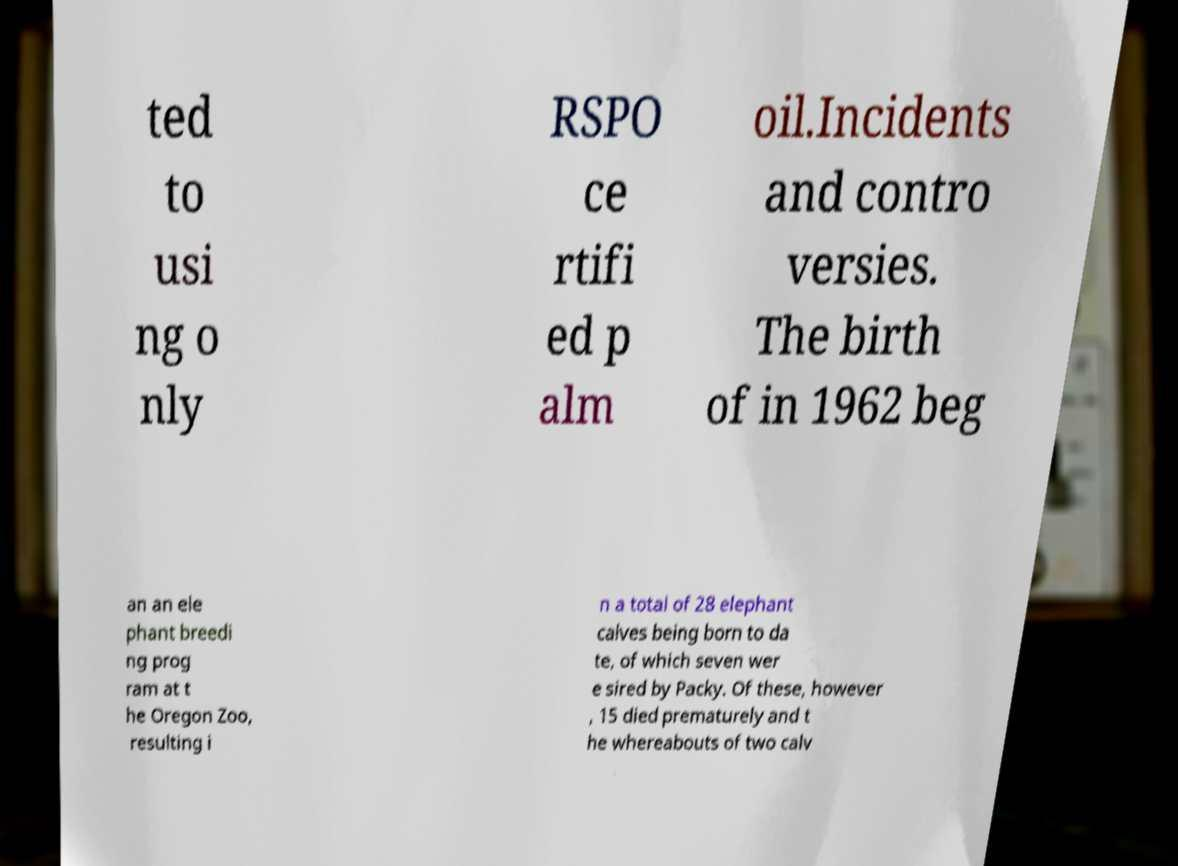Please identify and transcribe the text found in this image. ted to usi ng o nly RSPO ce rtifi ed p alm oil.Incidents and contro versies. The birth of in 1962 beg an an ele phant breedi ng prog ram at t he Oregon Zoo, resulting i n a total of 28 elephant calves being born to da te, of which seven wer e sired by Packy. Of these, however , 15 died prematurely and t he whereabouts of two calv 